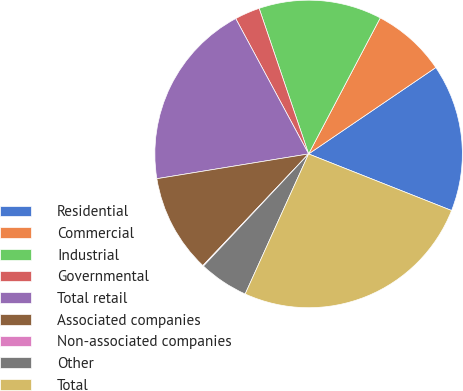Convert chart to OTSL. <chart><loc_0><loc_0><loc_500><loc_500><pie_chart><fcel>Residential<fcel>Commercial<fcel>Industrial<fcel>Governmental<fcel>Total retail<fcel>Associated companies<fcel>Non-associated companies<fcel>Other<fcel>Total<nl><fcel>15.5%<fcel>7.79%<fcel>12.93%<fcel>2.65%<fcel>19.72%<fcel>10.36%<fcel>0.08%<fcel>5.22%<fcel>25.78%<nl></chart> 